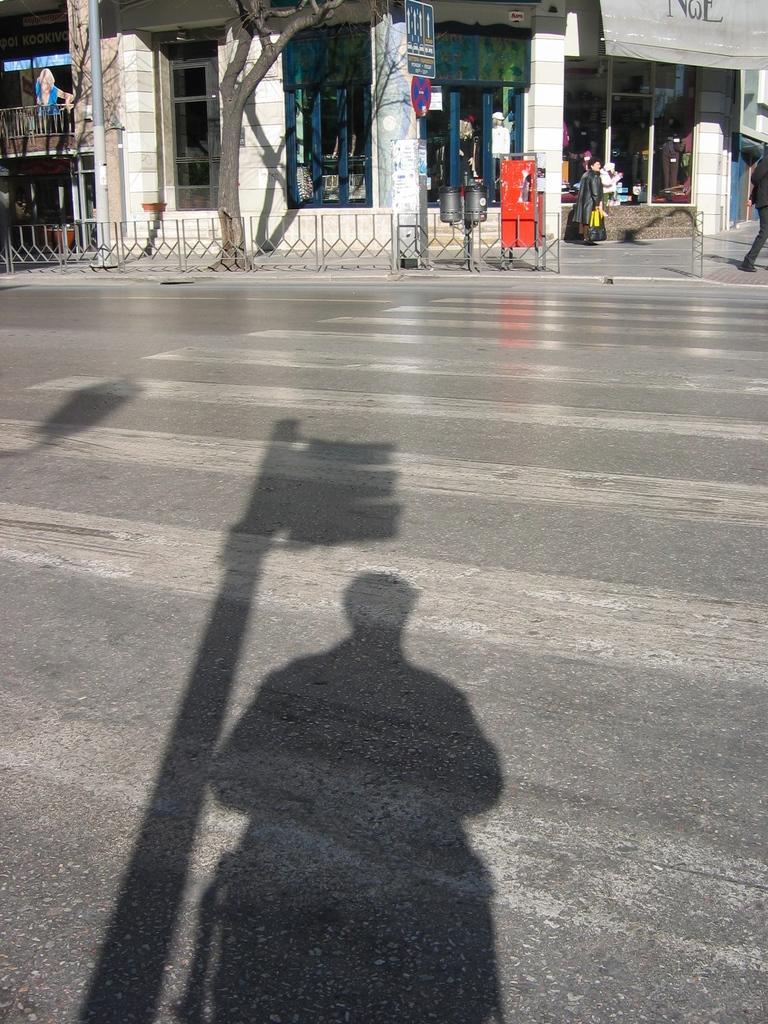Could you give a brief overview of what you see in this image? There are shadows on the road in the foreground, there is a tree, boundary, people, it seems like stalls, pole, pillars and other objects at the top side. 